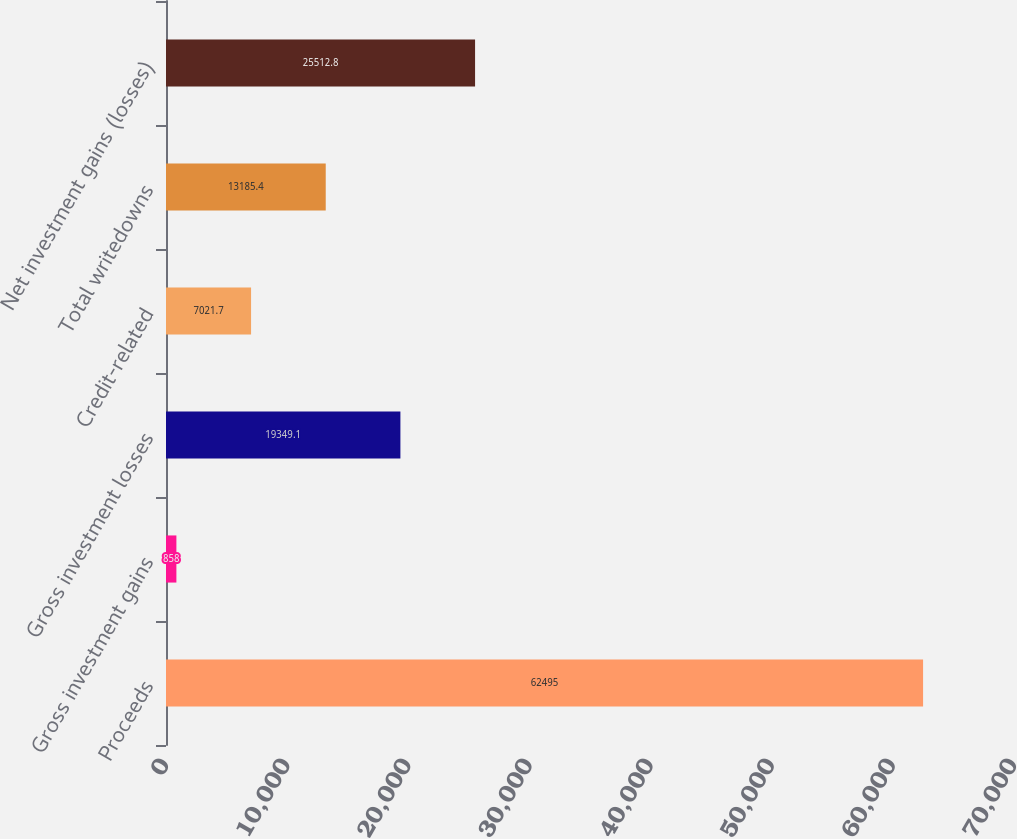Convert chart to OTSL. <chart><loc_0><loc_0><loc_500><loc_500><bar_chart><fcel>Proceeds<fcel>Gross investment gains<fcel>Gross investment losses<fcel>Credit-related<fcel>Total writedowns<fcel>Net investment gains (losses)<nl><fcel>62495<fcel>858<fcel>19349.1<fcel>7021.7<fcel>13185.4<fcel>25512.8<nl></chart> 